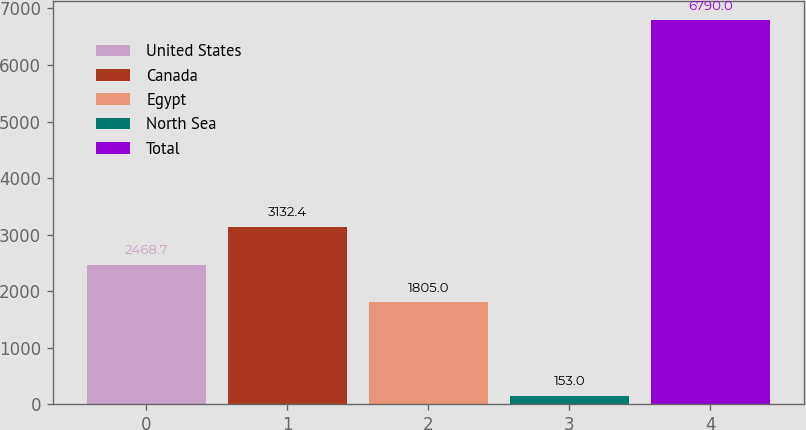Convert chart. <chart><loc_0><loc_0><loc_500><loc_500><bar_chart><fcel>United States<fcel>Canada<fcel>Egypt<fcel>North Sea<fcel>Total<nl><fcel>2468.7<fcel>3132.4<fcel>1805<fcel>153<fcel>6790<nl></chart> 